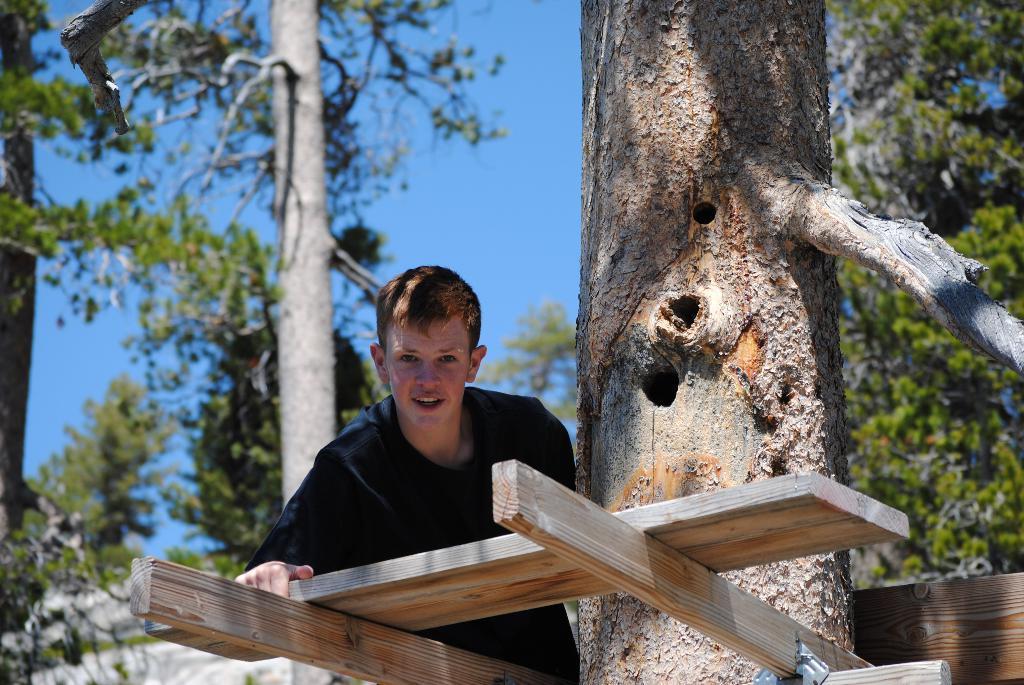In one or two sentences, can you explain what this image depicts? In the foreground of the picture there is a boy and there are wooden logs and trunk of a tree. The background is blurred. In the background there are trees. Sky is sunny. 